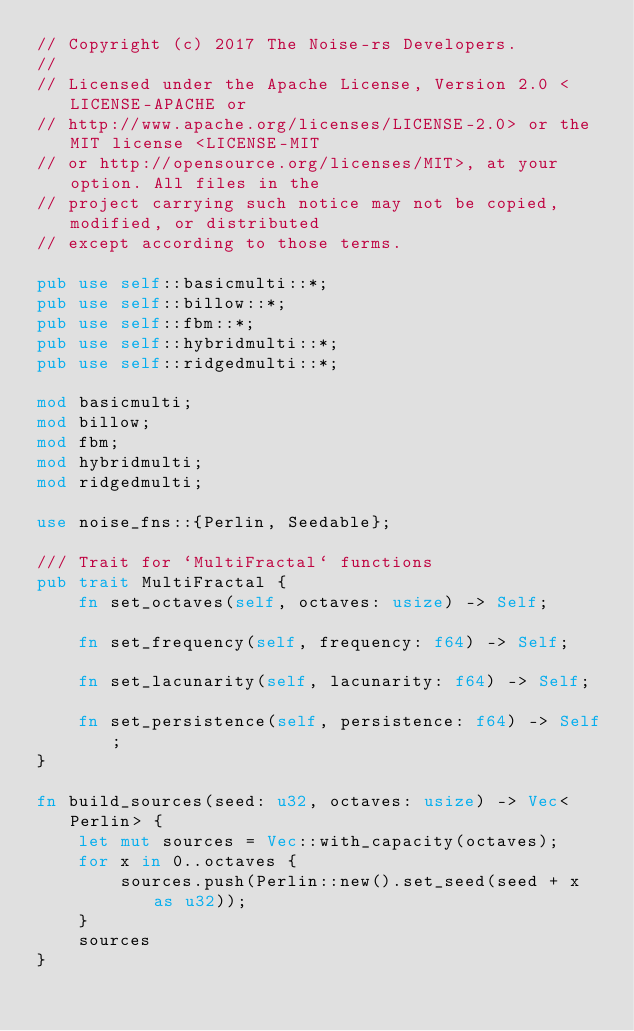Convert code to text. <code><loc_0><loc_0><loc_500><loc_500><_Rust_>// Copyright (c) 2017 The Noise-rs Developers.
//
// Licensed under the Apache License, Version 2.0 <LICENSE-APACHE or
// http://www.apache.org/licenses/LICENSE-2.0> or the MIT license <LICENSE-MIT
// or http://opensource.org/licenses/MIT>, at your option. All files in the
// project carrying such notice may not be copied, modified, or distributed
// except according to those terms.

pub use self::basicmulti::*;
pub use self::billow::*;
pub use self::fbm::*;
pub use self::hybridmulti::*;
pub use self::ridgedmulti::*;

mod basicmulti;
mod billow;
mod fbm;
mod hybridmulti;
mod ridgedmulti;

use noise_fns::{Perlin, Seedable};

/// Trait for `MultiFractal` functions
pub trait MultiFractal {
    fn set_octaves(self, octaves: usize) -> Self;

    fn set_frequency(self, frequency: f64) -> Self;

    fn set_lacunarity(self, lacunarity: f64) -> Self;

    fn set_persistence(self, persistence: f64) -> Self;
}

fn build_sources(seed: u32, octaves: usize) -> Vec<Perlin> {
    let mut sources = Vec::with_capacity(octaves);
    for x in 0..octaves {
        sources.push(Perlin::new().set_seed(seed + x as u32));
    }
    sources
}
</code> 